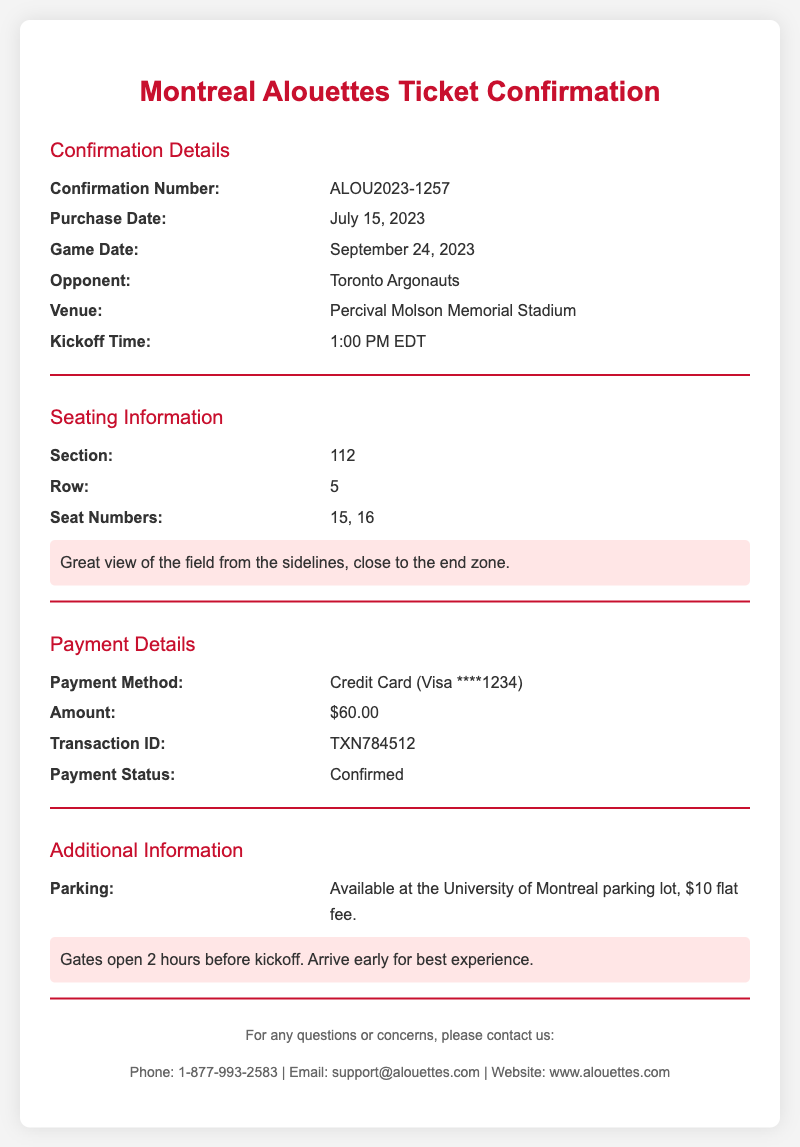What is the confirmation number? The confirmation number is listed in the confirmation details section of the document.
Answer: ALOU2023-1257 When is the game date? The game date is clearly stated in the confirmation details section of the document.
Answer: September 24, 2023 Who is the opponent? The opponent is mentioned in the confirmation details section of the document.
Answer: Toronto Argonauts What is the seating section? The seating section is provided in the seating information section of the document.
Answer: 112 What is the payment status? The payment status is included in the payment details section of the document.
Answer: Confirmed How much did the tickets cost? The ticket price is specified in the payment details section of the document.
Answer: $60.00 Where can I park? The parking information is detailed in the additional information section of the document.
Answer: University of Montreal parking lot What time do the gates open? The gate opening time is highlighted in the additional information section of the document.
Answer: 2 hours before kickoff What is the transaction ID? The transaction ID is found in the payment details section of the document.
Answer: TXN784512 